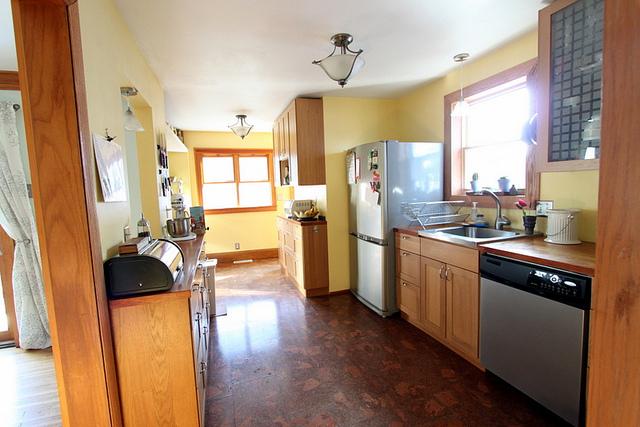Are all the appliances stainless steel?
Short answer required. Yes. What material is the floor made of?
Give a very brief answer. Tile. Why was this picture taken?
Short answer required. Real estate. Which room is this?
Short answer required. Kitchen. 